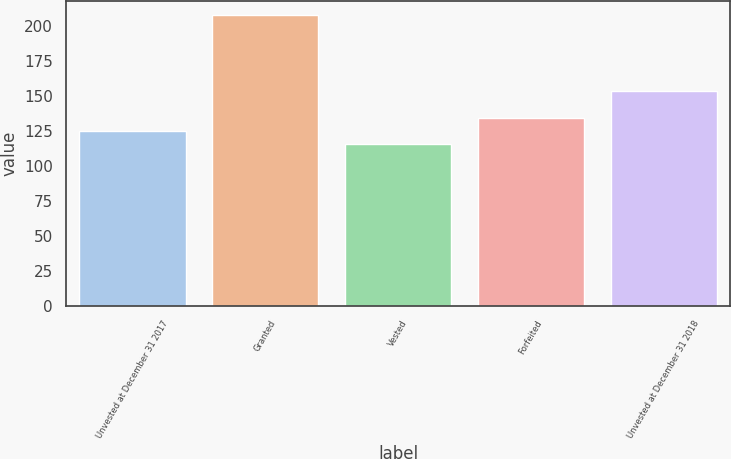Convert chart to OTSL. <chart><loc_0><loc_0><loc_500><loc_500><bar_chart><fcel>Unvested at December 31 2017<fcel>Granted<fcel>Vested<fcel>Forfeited<fcel>Unvested at December 31 2018<nl><fcel>124.96<fcel>207.85<fcel>115.75<fcel>134.17<fcel>153.31<nl></chart> 